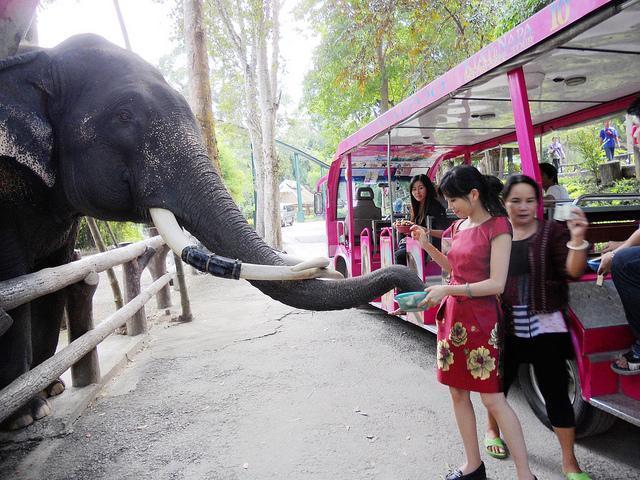Is the given caption "The elephant is facing away from the bus." fitting for the image?
Answer yes or no. No. Is the statement "The elephant is in front of the bus." accurate regarding the image?
Answer yes or no. No. Is "The bus is away from the elephant." an appropriate description for the image?
Answer yes or no. No. 